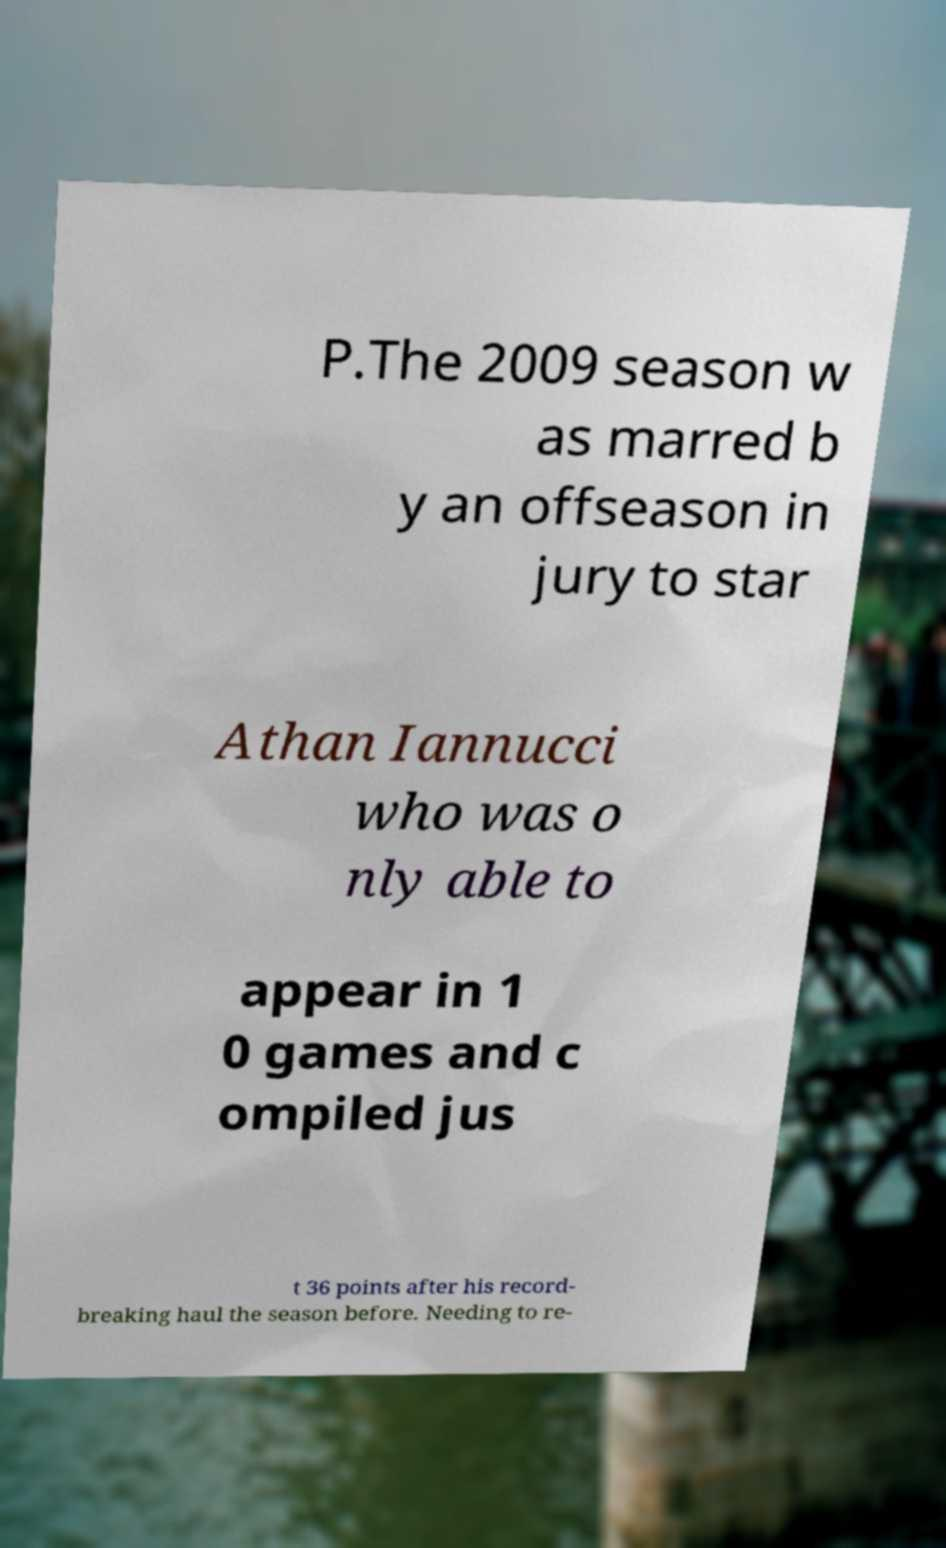Can you read and provide the text displayed in the image?This photo seems to have some interesting text. Can you extract and type it out for me? P.The 2009 season w as marred b y an offseason in jury to star Athan Iannucci who was o nly able to appear in 1 0 games and c ompiled jus t 36 points after his record- breaking haul the season before. Needing to re- 